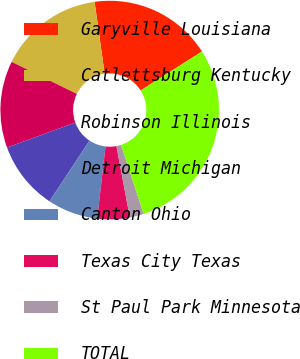Convert chart. <chart><loc_0><loc_0><loc_500><loc_500><pie_chart><fcel>Garyville Louisiana<fcel>Catlettsburg Kentucky<fcel>Robinson Illinois<fcel>Detroit Michigan<fcel>Canton Ohio<fcel>Texas City Texas<fcel>St Paul Park Minnesota<fcel>TOTAL<nl><fcel>18.21%<fcel>15.52%<fcel>12.84%<fcel>10.15%<fcel>7.46%<fcel>4.77%<fcel>2.08%<fcel>28.97%<nl></chart> 